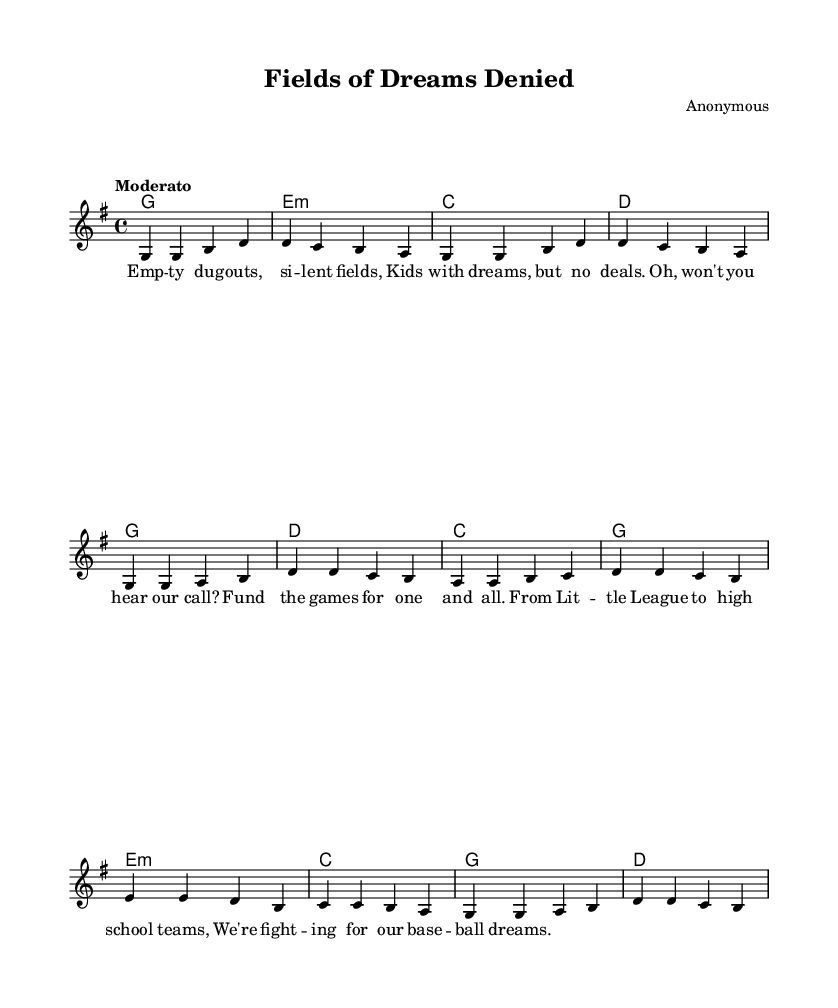What is the key signature of this music? The key signature is indicated at the beginning of the staff. The key of G major has one sharp (F#).
Answer: G major What is the time signature of the piece? The time signature is shown next to the key signature at the beginning of the score. It is 4/4, meaning there are four beats in each measure and the quarter note gets one beat.
Answer: 4/4 What is the tempo marking of the music? The tempo marking is provided at the beginning of the score, written above the staff. It indicates the speed at which the piece should be played, and in this case, it is marked as "Moderato."
Answer: Moderato How many measures are in the verse section? The verse section of the music consists of eight measures, as counted from the beginning to the end of that section.
Answer: Eight What is the chord progression for the first verse? The chord progression is labeled in the chord mode. The chords for the first verse are G, E minor, C, and D. This allows the musician to accompany the melody effectively.
Answer: G, E minor, C, D What social issue does this song address? The lyrics reflect a theme related to funding for grassroots sports organizations, emphasizing the need for financial support for youth sports. This is indicative of the protest song genre.
Answer: Funding for youth sports What type of protest is expressed in the lyrics? The lyrics express a call to action for funding and support for local baseball teams, highlighting the challenges faced by young athletes due to a lack of resources.
Answer: Support for local baseball teams 